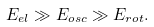Convert formula to latex. <formula><loc_0><loc_0><loc_500><loc_500>E _ { e l } \gg E _ { o s c } \gg E _ { r o t } .</formula> 